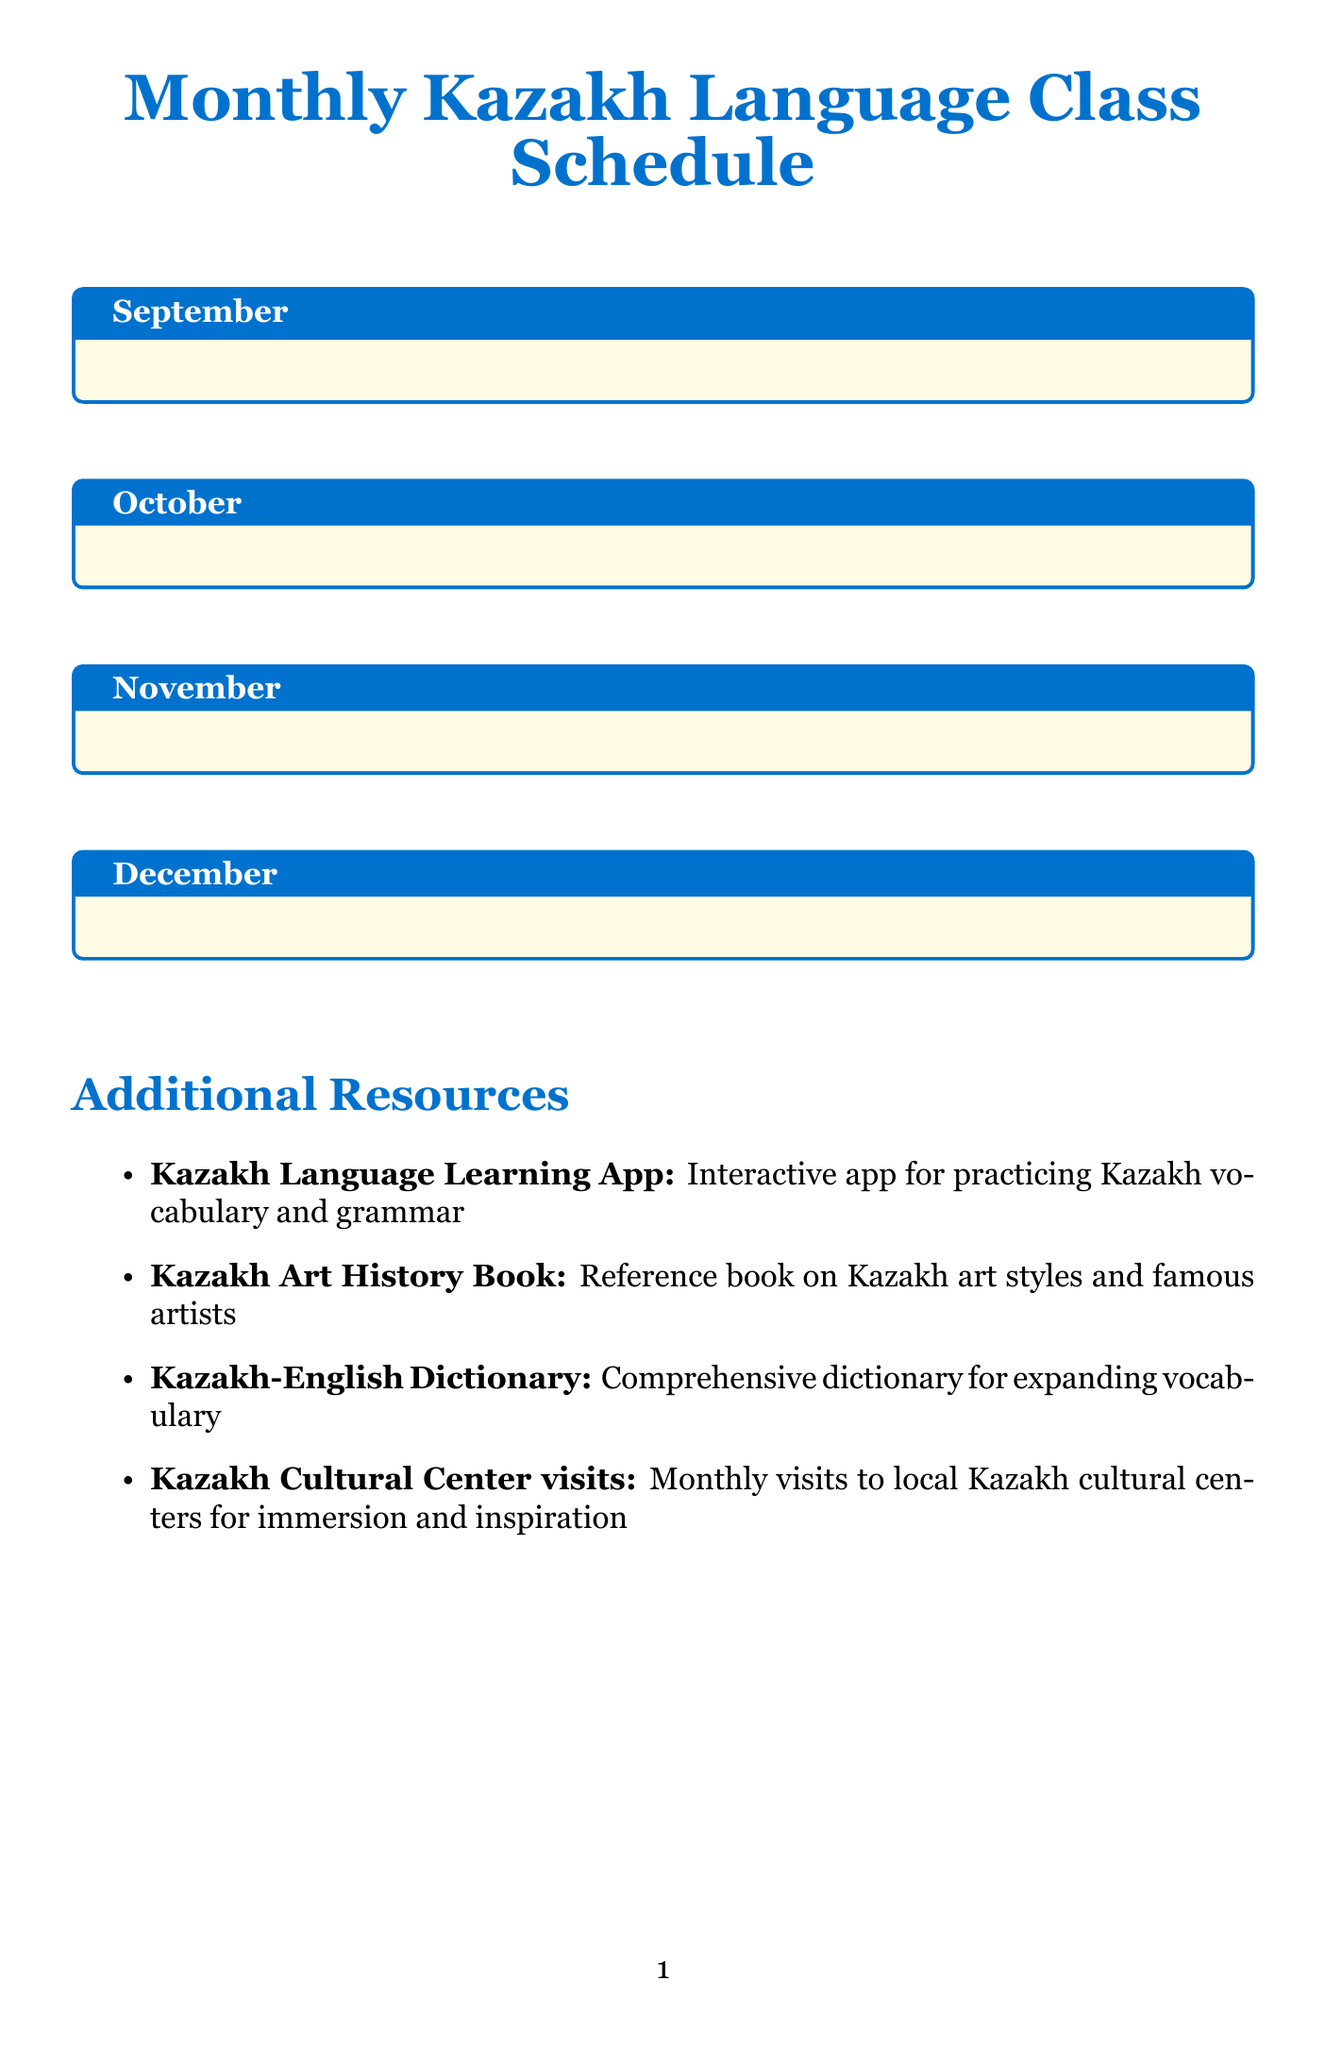What topic is covered in the first week of November? The first week of November focuses on Weather and Seasons.
Answer: Weather and Seasons What is the practice session for the second week of December? The practice session involves labeling parts of a yurt in Kazakh.
Answer: Labeling parts of a yurt in Kazakh How many lessons are there in October? The document lists 4 lessons for October.
Answer: 4 What traditional dish is learned in the third week of October? The lesson covers names of traditional Kazakh dishes like beshbarmak.
Answer: Beshbarmak What is included in the additional resources section? The additional resources list describes tools and activities to enhance learning, including apps and books.
Answer: Kazakh Language Learning App What is the topic of the fourth week in September? The fourth week of September focuses on Family Members and Relationships.
Answer: Family Members and Relationships Which musical instruments are studied in November? The lesson in the fourth week of November is about instruments like dombra and kobyz.
Answer: Dombra and kobyz How does the class in the second week of September prompt practical application? The second week of September involves counting traditional Kazakh jewelry pieces.
Answer: Counting traditional Kazakh jewelry pieces 